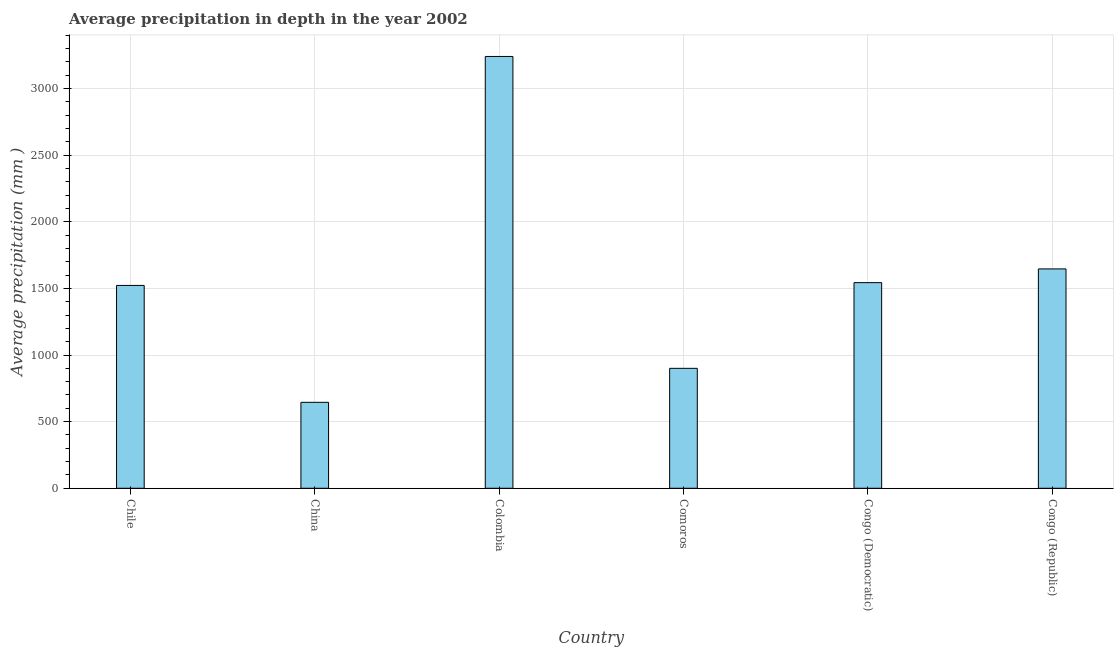Does the graph contain grids?
Make the answer very short. Yes. What is the title of the graph?
Make the answer very short. Average precipitation in depth in the year 2002. What is the label or title of the Y-axis?
Your response must be concise. Average precipitation (mm ). What is the average precipitation in depth in Colombia?
Offer a terse response. 3240. Across all countries, what is the maximum average precipitation in depth?
Your answer should be compact. 3240. Across all countries, what is the minimum average precipitation in depth?
Make the answer very short. 645. In which country was the average precipitation in depth minimum?
Your answer should be compact. China. What is the sum of the average precipitation in depth?
Your response must be concise. 9496. What is the difference between the average precipitation in depth in Colombia and Congo (Democratic)?
Give a very brief answer. 1697. What is the average average precipitation in depth per country?
Give a very brief answer. 1582. What is the median average precipitation in depth?
Keep it short and to the point. 1532.5. In how many countries, is the average precipitation in depth greater than 400 mm?
Provide a succinct answer. 6. What is the ratio of the average precipitation in depth in China to that in Congo (Republic)?
Your answer should be compact. 0.39. What is the difference between the highest and the second highest average precipitation in depth?
Your response must be concise. 1594. Is the sum of the average precipitation in depth in Chile and Congo (Democratic) greater than the maximum average precipitation in depth across all countries?
Provide a short and direct response. No. What is the difference between the highest and the lowest average precipitation in depth?
Your answer should be compact. 2595. In how many countries, is the average precipitation in depth greater than the average average precipitation in depth taken over all countries?
Offer a very short reply. 2. What is the Average precipitation (mm ) in Chile?
Provide a short and direct response. 1522. What is the Average precipitation (mm ) in China?
Offer a very short reply. 645. What is the Average precipitation (mm ) of Colombia?
Your answer should be compact. 3240. What is the Average precipitation (mm ) of Comoros?
Your answer should be compact. 900. What is the Average precipitation (mm ) in Congo (Democratic)?
Make the answer very short. 1543. What is the Average precipitation (mm ) in Congo (Republic)?
Make the answer very short. 1646. What is the difference between the Average precipitation (mm ) in Chile and China?
Provide a succinct answer. 877. What is the difference between the Average precipitation (mm ) in Chile and Colombia?
Offer a terse response. -1718. What is the difference between the Average precipitation (mm ) in Chile and Comoros?
Your answer should be very brief. 622. What is the difference between the Average precipitation (mm ) in Chile and Congo (Republic)?
Give a very brief answer. -124. What is the difference between the Average precipitation (mm ) in China and Colombia?
Ensure brevity in your answer.  -2595. What is the difference between the Average precipitation (mm ) in China and Comoros?
Offer a very short reply. -255. What is the difference between the Average precipitation (mm ) in China and Congo (Democratic)?
Your response must be concise. -898. What is the difference between the Average precipitation (mm ) in China and Congo (Republic)?
Your answer should be very brief. -1001. What is the difference between the Average precipitation (mm ) in Colombia and Comoros?
Offer a terse response. 2340. What is the difference between the Average precipitation (mm ) in Colombia and Congo (Democratic)?
Offer a terse response. 1697. What is the difference between the Average precipitation (mm ) in Colombia and Congo (Republic)?
Offer a terse response. 1594. What is the difference between the Average precipitation (mm ) in Comoros and Congo (Democratic)?
Offer a terse response. -643. What is the difference between the Average precipitation (mm ) in Comoros and Congo (Republic)?
Give a very brief answer. -746. What is the difference between the Average precipitation (mm ) in Congo (Democratic) and Congo (Republic)?
Provide a short and direct response. -103. What is the ratio of the Average precipitation (mm ) in Chile to that in China?
Give a very brief answer. 2.36. What is the ratio of the Average precipitation (mm ) in Chile to that in Colombia?
Your answer should be compact. 0.47. What is the ratio of the Average precipitation (mm ) in Chile to that in Comoros?
Ensure brevity in your answer.  1.69. What is the ratio of the Average precipitation (mm ) in Chile to that in Congo (Democratic)?
Give a very brief answer. 0.99. What is the ratio of the Average precipitation (mm ) in Chile to that in Congo (Republic)?
Your answer should be compact. 0.93. What is the ratio of the Average precipitation (mm ) in China to that in Colombia?
Keep it short and to the point. 0.2. What is the ratio of the Average precipitation (mm ) in China to that in Comoros?
Provide a succinct answer. 0.72. What is the ratio of the Average precipitation (mm ) in China to that in Congo (Democratic)?
Give a very brief answer. 0.42. What is the ratio of the Average precipitation (mm ) in China to that in Congo (Republic)?
Offer a terse response. 0.39. What is the ratio of the Average precipitation (mm ) in Colombia to that in Comoros?
Your response must be concise. 3.6. What is the ratio of the Average precipitation (mm ) in Colombia to that in Congo (Democratic)?
Your answer should be compact. 2.1. What is the ratio of the Average precipitation (mm ) in Colombia to that in Congo (Republic)?
Ensure brevity in your answer.  1.97. What is the ratio of the Average precipitation (mm ) in Comoros to that in Congo (Democratic)?
Make the answer very short. 0.58. What is the ratio of the Average precipitation (mm ) in Comoros to that in Congo (Republic)?
Offer a terse response. 0.55. What is the ratio of the Average precipitation (mm ) in Congo (Democratic) to that in Congo (Republic)?
Provide a succinct answer. 0.94. 